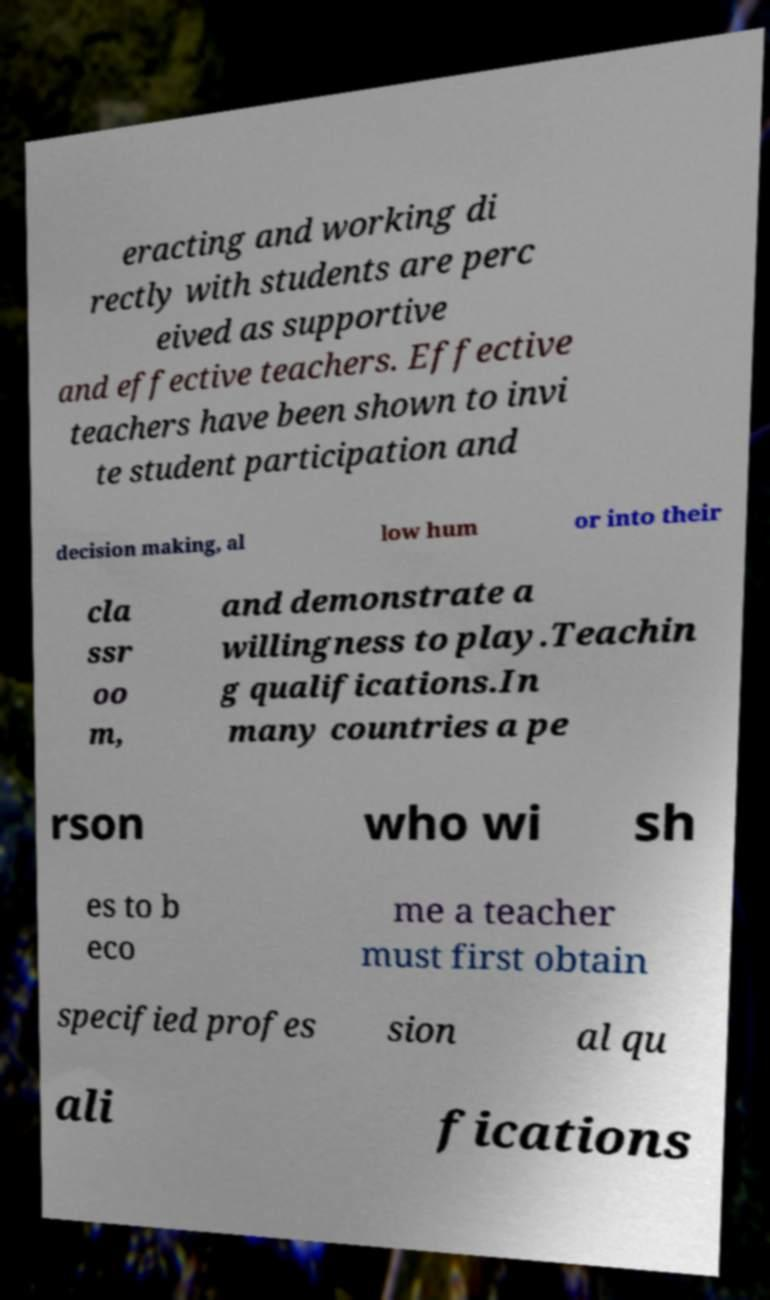Can you accurately transcribe the text from the provided image for me? eracting and working di rectly with students are perc eived as supportive and effective teachers. Effective teachers have been shown to invi te student participation and decision making, al low hum or into their cla ssr oo m, and demonstrate a willingness to play.Teachin g qualifications.In many countries a pe rson who wi sh es to b eco me a teacher must first obtain specified profes sion al qu ali fications 